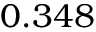Convert formula to latex. <formula><loc_0><loc_0><loc_500><loc_500>0 . 3 4 8</formula> 